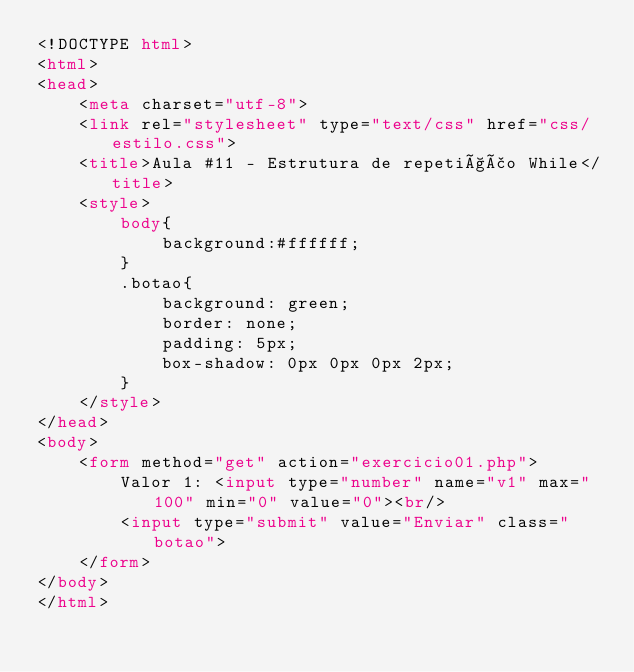Convert code to text. <code><loc_0><loc_0><loc_500><loc_500><_HTML_><!DOCTYPE html>
<html>
<head>
	<meta charset="utf-8">
	<link rel="stylesheet" type="text/css" href="css/estilo.css">
	<title>Aula #11 - Estrutura de repetição While</title>
	<style>
		body{
			background:#ffffff;
		}
		.botao{
			background: green;
			border: none;
			padding: 5px;
			box-shadow: 0px 0px 0px 2px;
		}
	</style>
</head>
<body>
	<form method="get" action="exercicio01.php"> 
		Valor 1: <input type="number" name="v1" max="100" min="0" value="0"><br/>
		<input type="submit" value="Enviar" class="botao">
	</form>
</body>
</html></code> 